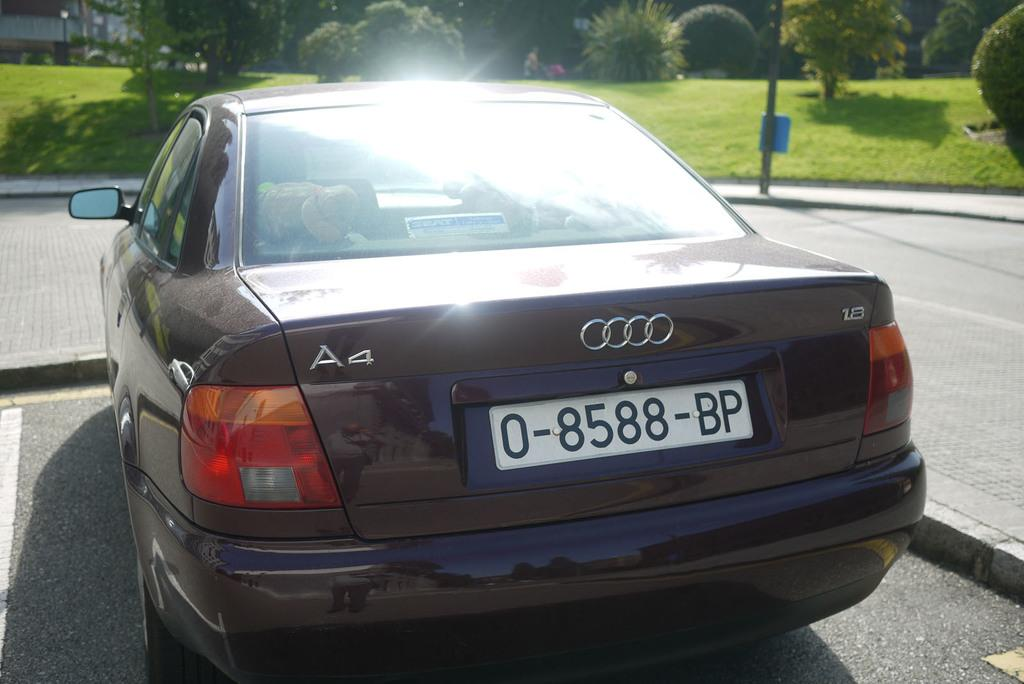<image>
Relay a brief, clear account of the picture shown. An A4 Audi says 1.8 on the right side of the trunk lid. 